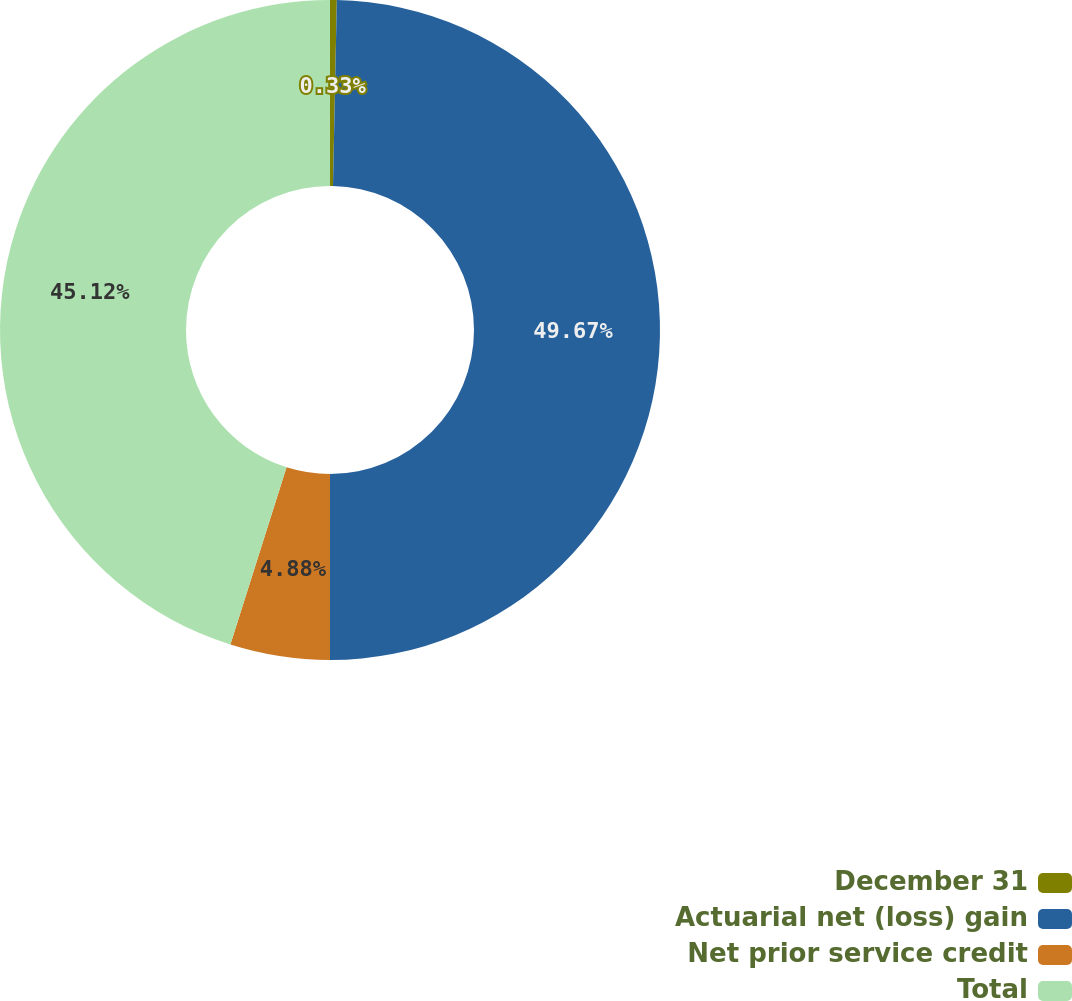Convert chart to OTSL. <chart><loc_0><loc_0><loc_500><loc_500><pie_chart><fcel>December 31<fcel>Actuarial net (loss) gain<fcel>Net prior service credit<fcel>Total<nl><fcel>0.33%<fcel>49.67%<fcel>4.88%<fcel>45.12%<nl></chart> 